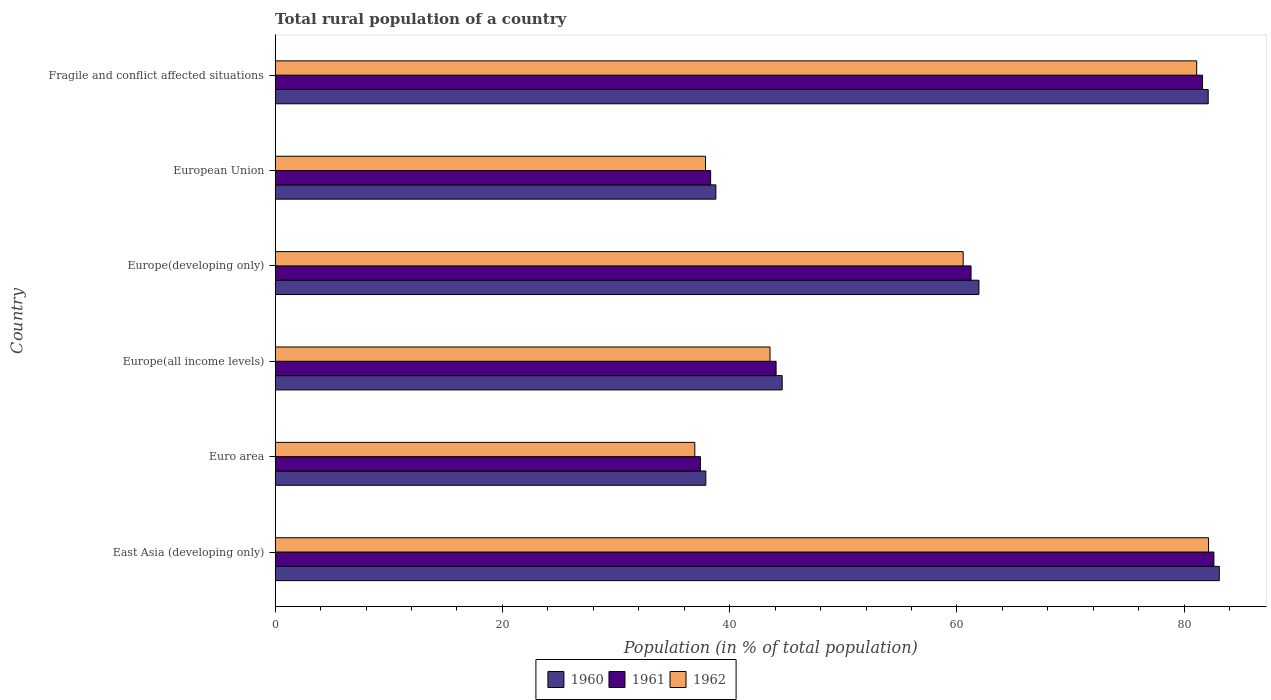Are the number of bars per tick equal to the number of legend labels?
Ensure brevity in your answer.  Yes. Are the number of bars on each tick of the Y-axis equal?
Offer a very short reply. Yes. How many bars are there on the 3rd tick from the top?
Provide a short and direct response. 3. How many bars are there on the 1st tick from the bottom?
Provide a succinct answer. 3. What is the label of the 4th group of bars from the top?
Your answer should be compact. Europe(all income levels). What is the rural population in 1961 in Europe(developing only)?
Offer a terse response. 61.24. Across all countries, what is the maximum rural population in 1961?
Offer a terse response. 82.61. Across all countries, what is the minimum rural population in 1960?
Offer a very short reply. 37.9. In which country was the rural population in 1961 maximum?
Keep it short and to the point. East Asia (developing only). In which country was the rural population in 1961 minimum?
Offer a very short reply. Euro area. What is the total rural population in 1962 in the graph?
Give a very brief answer. 342.13. What is the difference between the rural population in 1960 in European Union and that in Fragile and conflict affected situations?
Offer a very short reply. -43.32. What is the difference between the rural population in 1961 in European Union and the rural population in 1962 in Fragile and conflict affected situations?
Your response must be concise. -42.77. What is the average rural population in 1960 per country?
Ensure brevity in your answer.  58.07. What is the difference between the rural population in 1961 and rural population in 1960 in East Asia (developing only)?
Provide a succinct answer. -0.47. What is the ratio of the rural population in 1962 in East Asia (developing only) to that in European Union?
Provide a succinct answer. 2.17. What is the difference between the highest and the second highest rural population in 1961?
Ensure brevity in your answer.  1. What is the difference between the highest and the lowest rural population in 1960?
Give a very brief answer. 45.18. Is the sum of the rural population in 1962 in Europe(developing only) and Fragile and conflict affected situations greater than the maximum rural population in 1960 across all countries?
Give a very brief answer. Yes. Is it the case that in every country, the sum of the rural population in 1962 and rural population in 1961 is greater than the rural population in 1960?
Your answer should be compact. Yes. How many bars are there?
Provide a succinct answer. 18. Are all the bars in the graph horizontal?
Offer a terse response. Yes. How many countries are there in the graph?
Provide a short and direct response. 6. What is the difference between two consecutive major ticks on the X-axis?
Offer a terse response. 20. Are the values on the major ticks of X-axis written in scientific E-notation?
Make the answer very short. No. Does the graph contain grids?
Offer a terse response. No. Where does the legend appear in the graph?
Keep it short and to the point. Bottom center. How many legend labels are there?
Keep it short and to the point. 3. How are the legend labels stacked?
Keep it short and to the point. Horizontal. What is the title of the graph?
Give a very brief answer. Total rural population of a country. Does "1961" appear as one of the legend labels in the graph?
Offer a terse response. Yes. What is the label or title of the X-axis?
Your response must be concise. Population (in % of total population). What is the label or title of the Y-axis?
Make the answer very short. Country. What is the Population (in % of total population) in 1960 in East Asia (developing only)?
Provide a succinct answer. 83.08. What is the Population (in % of total population) in 1961 in East Asia (developing only)?
Give a very brief answer. 82.61. What is the Population (in % of total population) of 1962 in East Asia (developing only)?
Your response must be concise. 82.14. What is the Population (in % of total population) in 1960 in Euro area?
Offer a terse response. 37.9. What is the Population (in % of total population) of 1961 in Euro area?
Make the answer very short. 37.42. What is the Population (in % of total population) in 1962 in Euro area?
Your response must be concise. 36.93. What is the Population (in % of total population) of 1960 in Europe(all income levels)?
Offer a very short reply. 44.62. What is the Population (in % of total population) of 1961 in Europe(all income levels)?
Ensure brevity in your answer.  44.08. What is the Population (in % of total population) in 1962 in Europe(all income levels)?
Your answer should be very brief. 43.55. What is the Population (in % of total population) of 1960 in Europe(developing only)?
Offer a terse response. 61.93. What is the Population (in % of total population) of 1961 in Europe(developing only)?
Ensure brevity in your answer.  61.24. What is the Population (in % of total population) in 1962 in Europe(developing only)?
Your answer should be compact. 60.55. What is the Population (in % of total population) in 1960 in European Union?
Give a very brief answer. 38.79. What is the Population (in % of total population) of 1961 in European Union?
Provide a short and direct response. 38.33. What is the Population (in % of total population) in 1962 in European Union?
Offer a terse response. 37.87. What is the Population (in % of total population) of 1960 in Fragile and conflict affected situations?
Your answer should be compact. 82.11. What is the Population (in % of total population) in 1961 in Fragile and conflict affected situations?
Offer a terse response. 81.61. What is the Population (in % of total population) of 1962 in Fragile and conflict affected situations?
Your answer should be very brief. 81.09. Across all countries, what is the maximum Population (in % of total population) in 1960?
Keep it short and to the point. 83.08. Across all countries, what is the maximum Population (in % of total population) in 1961?
Offer a terse response. 82.61. Across all countries, what is the maximum Population (in % of total population) of 1962?
Your response must be concise. 82.14. Across all countries, what is the minimum Population (in % of total population) of 1960?
Provide a short and direct response. 37.9. Across all countries, what is the minimum Population (in % of total population) of 1961?
Your answer should be compact. 37.42. Across all countries, what is the minimum Population (in % of total population) of 1962?
Make the answer very short. 36.93. What is the total Population (in % of total population) of 1960 in the graph?
Offer a very short reply. 348.44. What is the total Population (in % of total population) in 1961 in the graph?
Provide a short and direct response. 345.3. What is the total Population (in % of total population) of 1962 in the graph?
Ensure brevity in your answer.  342.13. What is the difference between the Population (in % of total population) in 1960 in East Asia (developing only) and that in Euro area?
Keep it short and to the point. 45.18. What is the difference between the Population (in % of total population) in 1961 in East Asia (developing only) and that in Euro area?
Your answer should be compact. 45.18. What is the difference between the Population (in % of total population) of 1962 in East Asia (developing only) and that in Euro area?
Keep it short and to the point. 45.21. What is the difference between the Population (in % of total population) in 1960 in East Asia (developing only) and that in Europe(all income levels)?
Your answer should be very brief. 38.46. What is the difference between the Population (in % of total population) of 1961 in East Asia (developing only) and that in Europe(all income levels)?
Offer a very short reply. 38.52. What is the difference between the Population (in % of total population) in 1962 in East Asia (developing only) and that in Europe(all income levels)?
Keep it short and to the point. 38.59. What is the difference between the Population (in % of total population) in 1960 in East Asia (developing only) and that in Europe(developing only)?
Your response must be concise. 21.15. What is the difference between the Population (in % of total population) in 1961 in East Asia (developing only) and that in Europe(developing only)?
Your answer should be very brief. 21.37. What is the difference between the Population (in % of total population) of 1962 in East Asia (developing only) and that in Europe(developing only)?
Ensure brevity in your answer.  21.59. What is the difference between the Population (in % of total population) in 1960 in East Asia (developing only) and that in European Union?
Provide a succinct answer. 44.3. What is the difference between the Population (in % of total population) of 1961 in East Asia (developing only) and that in European Union?
Offer a very short reply. 44.28. What is the difference between the Population (in % of total population) in 1962 in East Asia (developing only) and that in European Union?
Provide a succinct answer. 44.26. What is the difference between the Population (in % of total population) in 1960 in East Asia (developing only) and that in Fragile and conflict affected situations?
Make the answer very short. 0.97. What is the difference between the Population (in % of total population) in 1961 in East Asia (developing only) and that in Fragile and conflict affected situations?
Provide a short and direct response. 1. What is the difference between the Population (in % of total population) in 1962 in East Asia (developing only) and that in Fragile and conflict affected situations?
Offer a terse response. 1.04. What is the difference between the Population (in % of total population) in 1960 in Euro area and that in Europe(all income levels)?
Keep it short and to the point. -6.72. What is the difference between the Population (in % of total population) in 1961 in Euro area and that in Europe(all income levels)?
Ensure brevity in your answer.  -6.66. What is the difference between the Population (in % of total population) in 1962 in Euro area and that in Europe(all income levels)?
Offer a terse response. -6.62. What is the difference between the Population (in % of total population) in 1960 in Euro area and that in Europe(developing only)?
Provide a succinct answer. -24.03. What is the difference between the Population (in % of total population) of 1961 in Euro area and that in Europe(developing only)?
Ensure brevity in your answer.  -23.82. What is the difference between the Population (in % of total population) of 1962 in Euro area and that in Europe(developing only)?
Provide a succinct answer. -23.62. What is the difference between the Population (in % of total population) in 1960 in Euro area and that in European Union?
Provide a short and direct response. -0.88. What is the difference between the Population (in % of total population) of 1961 in Euro area and that in European Union?
Your answer should be very brief. -0.9. What is the difference between the Population (in % of total population) in 1962 in Euro area and that in European Union?
Give a very brief answer. -0.94. What is the difference between the Population (in % of total population) of 1960 in Euro area and that in Fragile and conflict affected situations?
Provide a succinct answer. -44.2. What is the difference between the Population (in % of total population) in 1961 in Euro area and that in Fragile and conflict affected situations?
Ensure brevity in your answer.  -44.19. What is the difference between the Population (in % of total population) of 1962 in Euro area and that in Fragile and conflict affected situations?
Offer a very short reply. -44.16. What is the difference between the Population (in % of total population) of 1960 in Europe(all income levels) and that in Europe(developing only)?
Your answer should be very brief. -17.31. What is the difference between the Population (in % of total population) of 1961 in Europe(all income levels) and that in Europe(developing only)?
Provide a succinct answer. -17.16. What is the difference between the Population (in % of total population) in 1962 in Europe(all income levels) and that in Europe(developing only)?
Give a very brief answer. -17. What is the difference between the Population (in % of total population) of 1960 in Europe(all income levels) and that in European Union?
Your answer should be very brief. 5.83. What is the difference between the Population (in % of total population) of 1961 in Europe(all income levels) and that in European Union?
Your response must be concise. 5.76. What is the difference between the Population (in % of total population) in 1962 in Europe(all income levels) and that in European Union?
Provide a short and direct response. 5.68. What is the difference between the Population (in % of total population) in 1960 in Europe(all income levels) and that in Fragile and conflict affected situations?
Your answer should be very brief. -37.49. What is the difference between the Population (in % of total population) of 1961 in Europe(all income levels) and that in Fragile and conflict affected situations?
Ensure brevity in your answer.  -37.53. What is the difference between the Population (in % of total population) in 1962 in Europe(all income levels) and that in Fragile and conflict affected situations?
Your answer should be very brief. -37.54. What is the difference between the Population (in % of total population) of 1960 in Europe(developing only) and that in European Union?
Your answer should be compact. 23.15. What is the difference between the Population (in % of total population) of 1961 in Europe(developing only) and that in European Union?
Make the answer very short. 22.91. What is the difference between the Population (in % of total population) of 1962 in Europe(developing only) and that in European Union?
Make the answer very short. 22.67. What is the difference between the Population (in % of total population) of 1960 in Europe(developing only) and that in Fragile and conflict affected situations?
Offer a very short reply. -20.17. What is the difference between the Population (in % of total population) in 1961 in Europe(developing only) and that in Fragile and conflict affected situations?
Provide a short and direct response. -20.37. What is the difference between the Population (in % of total population) in 1962 in Europe(developing only) and that in Fragile and conflict affected situations?
Offer a terse response. -20.55. What is the difference between the Population (in % of total population) in 1960 in European Union and that in Fragile and conflict affected situations?
Provide a succinct answer. -43.32. What is the difference between the Population (in % of total population) of 1961 in European Union and that in Fragile and conflict affected situations?
Provide a succinct answer. -43.28. What is the difference between the Population (in % of total population) of 1962 in European Union and that in Fragile and conflict affected situations?
Your answer should be very brief. -43.22. What is the difference between the Population (in % of total population) of 1960 in East Asia (developing only) and the Population (in % of total population) of 1961 in Euro area?
Your answer should be very brief. 45.66. What is the difference between the Population (in % of total population) in 1960 in East Asia (developing only) and the Population (in % of total population) in 1962 in Euro area?
Provide a succinct answer. 46.15. What is the difference between the Population (in % of total population) in 1961 in East Asia (developing only) and the Population (in % of total population) in 1962 in Euro area?
Your response must be concise. 45.68. What is the difference between the Population (in % of total population) of 1960 in East Asia (developing only) and the Population (in % of total population) of 1961 in Europe(all income levels)?
Your response must be concise. 39. What is the difference between the Population (in % of total population) of 1960 in East Asia (developing only) and the Population (in % of total population) of 1962 in Europe(all income levels)?
Provide a succinct answer. 39.53. What is the difference between the Population (in % of total population) of 1961 in East Asia (developing only) and the Population (in % of total population) of 1962 in Europe(all income levels)?
Your answer should be compact. 39.06. What is the difference between the Population (in % of total population) of 1960 in East Asia (developing only) and the Population (in % of total population) of 1961 in Europe(developing only)?
Provide a short and direct response. 21.84. What is the difference between the Population (in % of total population) of 1960 in East Asia (developing only) and the Population (in % of total population) of 1962 in Europe(developing only)?
Your response must be concise. 22.54. What is the difference between the Population (in % of total population) of 1961 in East Asia (developing only) and the Population (in % of total population) of 1962 in Europe(developing only)?
Keep it short and to the point. 22.06. What is the difference between the Population (in % of total population) of 1960 in East Asia (developing only) and the Population (in % of total population) of 1961 in European Union?
Provide a succinct answer. 44.76. What is the difference between the Population (in % of total population) in 1960 in East Asia (developing only) and the Population (in % of total population) in 1962 in European Union?
Your response must be concise. 45.21. What is the difference between the Population (in % of total population) in 1961 in East Asia (developing only) and the Population (in % of total population) in 1962 in European Union?
Your answer should be very brief. 44.74. What is the difference between the Population (in % of total population) in 1960 in East Asia (developing only) and the Population (in % of total population) in 1961 in Fragile and conflict affected situations?
Keep it short and to the point. 1.47. What is the difference between the Population (in % of total population) of 1960 in East Asia (developing only) and the Population (in % of total population) of 1962 in Fragile and conflict affected situations?
Offer a terse response. 1.99. What is the difference between the Population (in % of total population) in 1961 in East Asia (developing only) and the Population (in % of total population) in 1962 in Fragile and conflict affected situations?
Your answer should be very brief. 1.52. What is the difference between the Population (in % of total population) in 1960 in Euro area and the Population (in % of total population) in 1961 in Europe(all income levels)?
Provide a succinct answer. -6.18. What is the difference between the Population (in % of total population) of 1960 in Euro area and the Population (in % of total population) of 1962 in Europe(all income levels)?
Provide a short and direct response. -5.65. What is the difference between the Population (in % of total population) in 1961 in Euro area and the Population (in % of total population) in 1962 in Europe(all income levels)?
Provide a succinct answer. -6.13. What is the difference between the Population (in % of total population) in 1960 in Euro area and the Population (in % of total population) in 1961 in Europe(developing only)?
Your response must be concise. -23.34. What is the difference between the Population (in % of total population) in 1960 in Euro area and the Population (in % of total population) in 1962 in Europe(developing only)?
Give a very brief answer. -22.64. What is the difference between the Population (in % of total population) of 1961 in Euro area and the Population (in % of total population) of 1962 in Europe(developing only)?
Keep it short and to the point. -23.12. What is the difference between the Population (in % of total population) of 1960 in Euro area and the Population (in % of total population) of 1961 in European Union?
Offer a very short reply. -0.42. What is the difference between the Population (in % of total population) of 1960 in Euro area and the Population (in % of total population) of 1962 in European Union?
Provide a succinct answer. 0.03. What is the difference between the Population (in % of total population) in 1961 in Euro area and the Population (in % of total population) in 1962 in European Union?
Offer a very short reply. -0.45. What is the difference between the Population (in % of total population) of 1960 in Euro area and the Population (in % of total population) of 1961 in Fragile and conflict affected situations?
Provide a succinct answer. -43.71. What is the difference between the Population (in % of total population) in 1960 in Euro area and the Population (in % of total population) in 1962 in Fragile and conflict affected situations?
Your answer should be compact. -43.19. What is the difference between the Population (in % of total population) of 1961 in Euro area and the Population (in % of total population) of 1962 in Fragile and conflict affected situations?
Make the answer very short. -43.67. What is the difference between the Population (in % of total population) in 1960 in Europe(all income levels) and the Population (in % of total population) in 1961 in Europe(developing only)?
Give a very brief answer. -16.62. What is the difference between the Population (in % of total population) in 1960 in Europe(all income levels) and the Population (in % of total population) in 1962 in Europe(developing only)?
Ensure brevity in your answer.  -15.93. What is the difference between the Population (in % of total population) in 1961 in Europe(all income levels) and the Population (in % of total population) in 1962 in Europe(developing only)?
Your response must be concise. -16.46. What is the difference between the Population (in % of total population) in 1960 in Europe(all income levels) and the Population (in % of total population) in 1961 in European Union?
Provide a short and direct response. 6.29. What is the difference between the Population (in % of total population) in 1960 in Europe(all income levels) and the Population (in % of total population) in 1962 in European Union?
Ensure brevity in your answer.  6.75. What is the difference between the Population (in % of total population) in 1961 in Europe(all income levels) and the Population (in % of total population) in 1962 in European Union?
Offer a very short reply. 6.21. What is the difference between the Population (in % of total population) in 1960 in Europe(all income levels) and the Population (in % of total population) in 1961 in Fragile and conflict affected situations?
Ensure brevity in your answer.  -36.99. What is the difference between the Population (in % of total population) of 1960 in Europe(all income levels) and the Population (in % of total population) of 1962 in Fragile and conflict affected situations?
Provide a short and direct response. -36.47. What is the difference between the Population (in % of total population) in 1961 in Europe(all income levels) and the Population (in % of total population) in 1962 in Fragile and conflict affected situations?
Provide a short and direct response. -37.01. What is the difference between the Population (in % of total population) in 1960 in Europe(developing only) and the Population (in % of total population) in 1961 in European Union?
Your answer should be very brief. 23.61. What is the difference between the Population (in % of total population) in 1960 in Europe(developing only) and the Population (in % of total population) in 1962 in European Union?
Make the answer very short. 24.06. What is the difference between the Population (in % of total population) of 1961 in Europe(developing only) and the Population (in % of total population) of 1962 in European Union?
Make the answer very short. 23.37. What is the difference between the Population (in % of total population) in 1960 in Europe(developing only) and the Population (in % of total population) in 1961 in Fragile and conflict affected situations?
Your answer should be very brief. -19.68. What is the difference between the Population (in % of total population) of 1960 in Europe(developing only) and the Population (in % of total population) of 1962 in Fragile and conflict affected situations?
Offer a terse response. -19.16. What is the difference between the Population (in % of total population) in 1961 in Europe(developing only) and the Population (in % of total population) in 1962 in Fragile and conflict affected situations?
Provide a succinct answer. -19.85. What is the difference between the Population (in % of total population) of 1960 in European Union and the Population (in % of total population) of 1961 in Fragile and conflict affected situations?
Your answer should be very brief. -42.82. What is the difference between the Population (in % of total population) of 1960 in European Union and the Population (in % of total population) of 1962 in Fragile and conflict affected situations?
Your response must be concise. -42.31. What is the difference between the Population (in % of total population) in 1961 in European Union and the Population (in % of total population) in 1962 in Fragile and conflict affected situations?
Offer a terse response. -42.77. What is the average Population (in % of total population) of 1960 per country?
Offer a very short reply. 58.07. What is the average Population (in % of total population) of 1961 per country?
Your answer should be compact. 57.55. What is the average Population (in % of total population) of 1962 per country?
Keep it short and to the point. 57.02. What is the difference between the Population (in % of total population) in 1960 and Population (in % of total population) in 1961 in East Asia (developing only)?
Ensure brevity in your answer.  0.47. What is the difference between the Population (in % of total population) of 1960 and Population (in % of total population) of 1962 in East Asia (developing only)?
Give a very brief answer. 0.95. What is the difference between the Population (in % of total population) of 1961 and Population (in % of total population) of 1962 in East Asia (developing only)?
Ensure brevity in your answer.  0.47. What is the difference between the Population (in % of total population) in 1960 and Population (in % of total population) in 1961 in Euro area?
Keep it short and to the point. 0.48. What is the difference between the Population (in % of total population) of 1960 and Population (in % of total population) of 1962 in Euro area?
Provide a succinct answer. 0.97. What is the difference between the Population (in % of total population) in 1961 and Population (in % of total population) in 1962 in Euro area?
Give a very brief answer. 0.49. What is the difference between the Population (in % of total population) of 1960 and Population (in % of total population) of 1961 in Europe(all income levels)?
Give a very brief answer. 0.54. What is the difference between the Population (in % of total population) of 1960 and Population (in % of total population) of 1962 in Europe(all income levels)?
Your answer should be compact. 1.07. What is the difference between the Population (in % of total population) in 1961 and Population (in % of total population) in 1962 in Europe(all income levels)?
Offer a terse response. 0.53. What is the difference between the Population (in % of total population) of 1960 and Population (in % of total population) of 1961 in Europe(developing only)?
Provide a short and direct response. 0.69. What is the difference between the Population (in % of total population) of 1960 and Population (in % of total population) of 1962 in Europe(developing only)?
Offer a very short reply. 1.39. What is the difference between the Population (in % of total population) in 1961 and Population (in % of total population) in 1962 in Europe(developing only)?
Your answer should be very brief. 0.69. What is the difference between the Population (in % of total population) of 1960 and Population (in % of total population) of 1961 in European Union?
Offer a very short reply. 0.46. What is the difference between the Population (in % of total population) in 1960 and Population (in % of total population) in 1962 in European Union?
Keep it short and to the point. 0.91. What is the difference between the Population (in % of total population) of 1961 and Population (in % of total population) of 1962 in European Union?
Your answer should be compact. 0.45. What is the difference between the Population (in % of total population) of 1960 and Population (in % of total population) of 1961 in Fragile and conflict affected situations?
Your answer should be compact. 0.5. What is the difference between the Population (in % of total population) in 1960 and Population (in % of total population) in 1962 in Fragile and conflict affected situations?
Make the answer very short. 1.02. What is the difference between the Population (in % of total population) in 1961 and Population (in % of total population) in 1962 in Fragile and conflict affected situations?
Your answer should be very brief. 0.52. What is the ratio of the Population (in % of total population) of 1960 in East Asia (developing only) to that in Euro area?
Give a very brief answer. 2.19. What is the ratio of the Population (in % of total population) in 1961 in East Asia (developing only) to that in Euro area?
Provide a short and direct response. 2.21. What is the ratio of the Population (in % of total population) of 1962 in East Asia (developing only) to that in Euro area?
Ensure brevity in your answer.  2.22. What is the ratio of the Population (in % of total population) of 1960 in East Asia (developing only) to that in Europe(all income levels)?
Provide a short and direct response. 1.86. What is the ratio of the Population (in % of total population) of 1961 in East Asia (developing only) to that in Europe(all income levels)?
Your answer should be very brief. 1.87. What is the ratio of the Population (in % of total population) in 1962 in East Asia (developing only) to that in Europe(all income levels)?
Keep it short and to the point. 1.89. What is the ratio of the Population (in % of total population) in 1960 in East Asia (developing only) to that in Europe(developing only)?
Offer a very short reply. 1.34. What is the ratio of the Population (in % of total population) of 1961 in East Asia (developing only) to that in Europe(developing only)?
Your response must be concise. 1.35. What is the ratio of the Population (in % of total population) in 1962 in East Asia (developing only) to that in Europe(developing only)?
Provide a short and direct response. 1.36. What is the ratio of the Population (in % of total population) in 1960 in East Asia (developing only) to that in European Union?
Your response must be concise. 2.14. What is the ratio of the Population (in % of total population) in 1961 in East Asia (developing only) to that in European Union?
Provide a succinct answer. 2.16. What is the ratio of the Population (in % of total population) in 1962 in East Asia (developing only) to that in European Union?
Keep it short and to the point. 2.17. What is the ratio of the Population (in % of total population) of 1960 in East Asia (developing only) to that in Fragile and conflict affected situations?
Provide a short and direct response. 1.01. What is the ratio of the Population (in % of total population) of 1961 in East Asia (developing only) to that in Fragile and conflict affected situations?
Give a very brief answer. 1.01. What is the ratio of the Population (in % of total population) in 1962 in East Asia (developing only) to that in Fragile and conflict affected situations?
Provide a succinct answer. 1.01. What is the ratio of the Population (in % of total population) of 1960 in Euro area to that in Europe(all income levels)?
Your response must be concise. 0.85. What is the ratio of the Population (in % of total population) of 1961 in Euro area to that in Europe(all income levels)?
Ensure brevity in your answer.  0.85. What is the ratio of the Population (in % of total population) of 1962 in Euro area to that in Europe(all income levels)?
Your answer should be very brief. 0.85. What is the ratio of the Population (in % of total population) in 1960 in Euro area to that in Europe(developing only)?
Offer a terse response. 0.61. What is the ratio of the Population (in % of total population) in 1961 in Euro area to that in Europe(developing only)?
Offer a terse response. 0.61. What is the ratio of the Population (in % of total population) of 1962 in Euro area to that in Europe(developing only)?
Your answer should be compact. 0.61. What is the ratio of the Population (in % of total population) of 1960 in Euro area to that in European Union?
Make the answer very short. 0.98. What is the ratio of the Population (in % of total population) in 1961 in Euro area to that in European Union?
Offer a very short reply. 0.98. What is the ratio of the Population (in % of total population) of 1962 in Euro area to that in European Union?
Offer a very short reply. 0.98. What is the ratio of the Population (in % of total population) in 1960 in Euro area to that in Fragile and conflict affected situations?
Provide a short and direct response. 0.46. What is the ratio of the Population (in % of total population) of 1961 in Euro area to that in Fragile and conflict affected situations?
Your answer should be compact. 0.46. What is the ratio of the Population (in % of total population) in 1962 in Euro area to that in Fragile and conflict affected situations?
Offer a very short reply. 0.46. What is the ratio of the Population (in % of total population) of 1960 in Europe(all income levels) to that in Europe(developing only)?
Provide a short and direct response. 0.72. What is the ratio of the Population (in % of total population) of 1961 in Europe(all income levels) to that in Europe(developing only)?
Provide a succinct answer. 0.72. What is the ratio of the Population (in % of total population) of 1962 in Europe(all income levels) to that in Europe(developing only)?
Provide a succinct answer. 0.72. What is the ratio of the Population (in % of total population) of 1960 in Europe(all income levels) to that in European Union?
Offer a terse response. 1.15. What is the ratio of the Population (in % of total population) in 1961 in Europe(all income levels) to that in European Union?
Keep it short and to the point. 1.15. What is the ratio of the Population (in % of total population) of 1962 in Europe(all income levels) to that in European Union?
Your response must be concise. 1.15. What is the ratio of the Population (in % of total population) of 1960 in Europe(all income levels) to that in Fragile and conflict affected situations?
Keep it short and to the point. 0.54. What is the ratio of the Population (in % of total population) in 1961 in Europe(all income levels) to that in Fragile and conflict affected situations?
Your response must be concise. 0.54. What is the ratio of the Population (in % of total population) of 1962 in Europe(all income levels) to that in Fragile and conflict affected situations?
Your answer should be very brief. 0.54. What is the ratio of the Population (in % of total population) of 1960 in Europe(developing only) to that in European Union?
Keep it short and to the point. 1.6. What is the ratio of the Population (in % of total population) in 1961 in Europe(developing only) to that in European Union?
Your answer should be very brief. 1.6. What is the ratio of the Population (in % of total population) in 1962 in Europe(developing only) to that in European Union?
Ensure brevity in your answer.  1.6. What is the ratio of the Population (in % of total population) of 1960 in Europe(developing only) to that in Fragile and conflict affected situations?
Provide a short and direct response. 0.75. What is the ratio of the Population (in % of total population) in 1961 in Europe(developing only) to that in Fragile and conflict affected situations?
Your answer should be very brief. 0.75. What is the ratio of the Population (in % of total population) in 1962 in Europe(developing only) to that in Fragile and conflict affected situations?
Give a very brief answer. 0.75. What is the ratio of the Population (in % of total population) in 1960 in European Union to that in Fragile and conflict affected situations?
Offer a very short reply. 0.47. What is the ratio of the Population (in % of total population) in 1961 in European Union to that in Fragile and conflict affected situations?
Offer a very short reply. 0.47. What is the ratio of the Population (in % of total population) of 1962 in European Union to that in Fragile and conflict affected situations?
Offer a very short reply. 0.47. What is the difference between the highest and the second highest Population (in % of total population) of 1960?
Provide a succinct answer. 0.97. What is the difference between the highest and the second highest Population (in % of total population) in 1961?
Your response must be concise. 1. What is the difference between the highest and the second highest Population (in % of total population) of 1962?
Provide a short and direct response. 1.04. What is the difference between the highest and the lowest Population (in % of total population) in 1960?
Make the answer very short. 45.18. What is the difference between the highest and the lowest Population (in % of total population) of 1961?
Provide a short and direct response. 45.18. What is the difference between the highest and the lowest Population (in % of total population) in 1962?
Offer a very short reply. 45.21. 